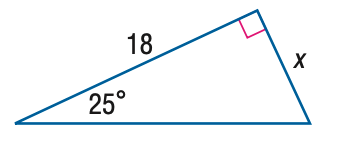Answer the mathemtical geometry problem and directly provide the correct option letter.
Question: Find x to the nearest hundredth.
Choices: A: 7.61 B: 8.39 C: 16.31 D: 18.00 B 